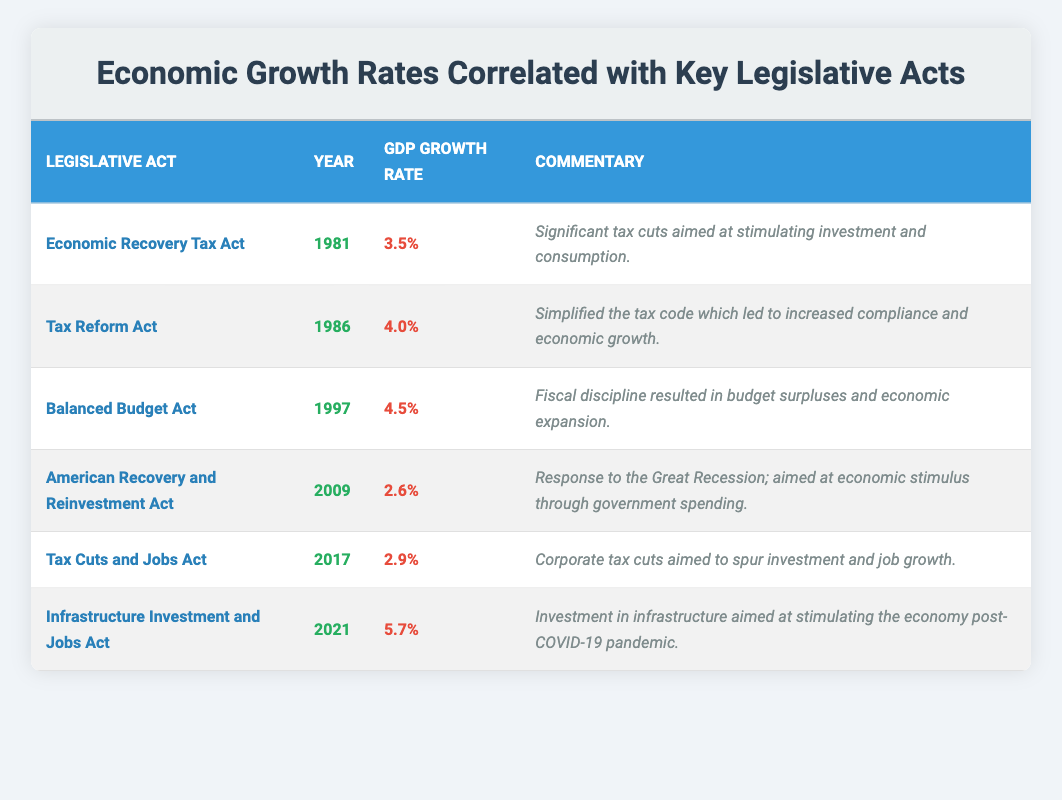What is the GDP growth rate associated with the Balanced Budget Act? The table shows the GDP growth rate for the Balanced Budget Act as 4.5%.
Answer: 4.5% Which legislative act was enacted in 2009 and what was its GDP growth rate? The American Recovery and Reinvestment Act was enacted in 2009 and had a GDP growth rate of 2.6%.
Answer: 2.6% What is the difference in GDP growth rates between the Infrastructure Investment and Jobs Act and the Tax Cuts and Jobs Act? The Infrastructure Investment and Jobs Act has a GDP growth rate of 5.7%, and the Tax Cuts and Jobs Act has a rate of 2.9%. The difference is 5.7% - 2.9% = 2.8%.
Answer: 2.8% Which legislative act had the highest GDP growth rate, and what was that rate? The Infrastructure Investment and Jobs Act had the highest GDP growth rate of 5.7%.
Answer: 5.7% Is the GDP growth rate for the Tax Reform Act greater than that of the American Recovery and Reinvestment Act? The Tax Reform Act has a growth rate of 4.0%, while the American Recovery and Reinvestment Act has 2.6%. Since 4.0% > 2.6%, the statement is true.
Answer: Yes What was the average GDP growth rate for the acts between 1981 and 2009? The growth rates for those years are 3.5%, 4.0%, 4.5%, and 2.6%. The total is 3.5 + 4.0 + 4.5 + 2.6 = 14.6%, and there are 4 acts, so the average is 14.6% / 4 = 3.65%.
Answer: 3.65% How many acts had a GDP growth rate of over 4%? The acts with over 4% growth rates are the Tax Reform Act (4.0%), the Balanced Budget Act (4.5%), and the Infrastructure Investment and Jobs Act (5.7%). Total acts over 4% are 3.
Answer: 3 Was there a legislative act in the table with a GDP growth rate below 3%? The lowest growth rate in the table is 2.6% for the American Recovery and Reinvestment Act. Therefore, there was indeed an act with a growth rate below 3%.
Answer: Yes What is the trend in GDP growth rates from 1981 to 2021 represented in the table? The GDP growth rates varied, starting at 3.5% in 1981, peaking at 5.7% in 2021, and showing both increases and decreases over the years.
Answer: Increasing trend overall Which two acts had the lowest GDP growth rates? The two acts with the lowest growth rates are the American Recovery and Reinvestment Act (2.6%) and the Tax Cuts and Jobs Act (2.9%).
Answer: American Recovery and Reinvestment Act and Tax Cuts and Jobs Act 